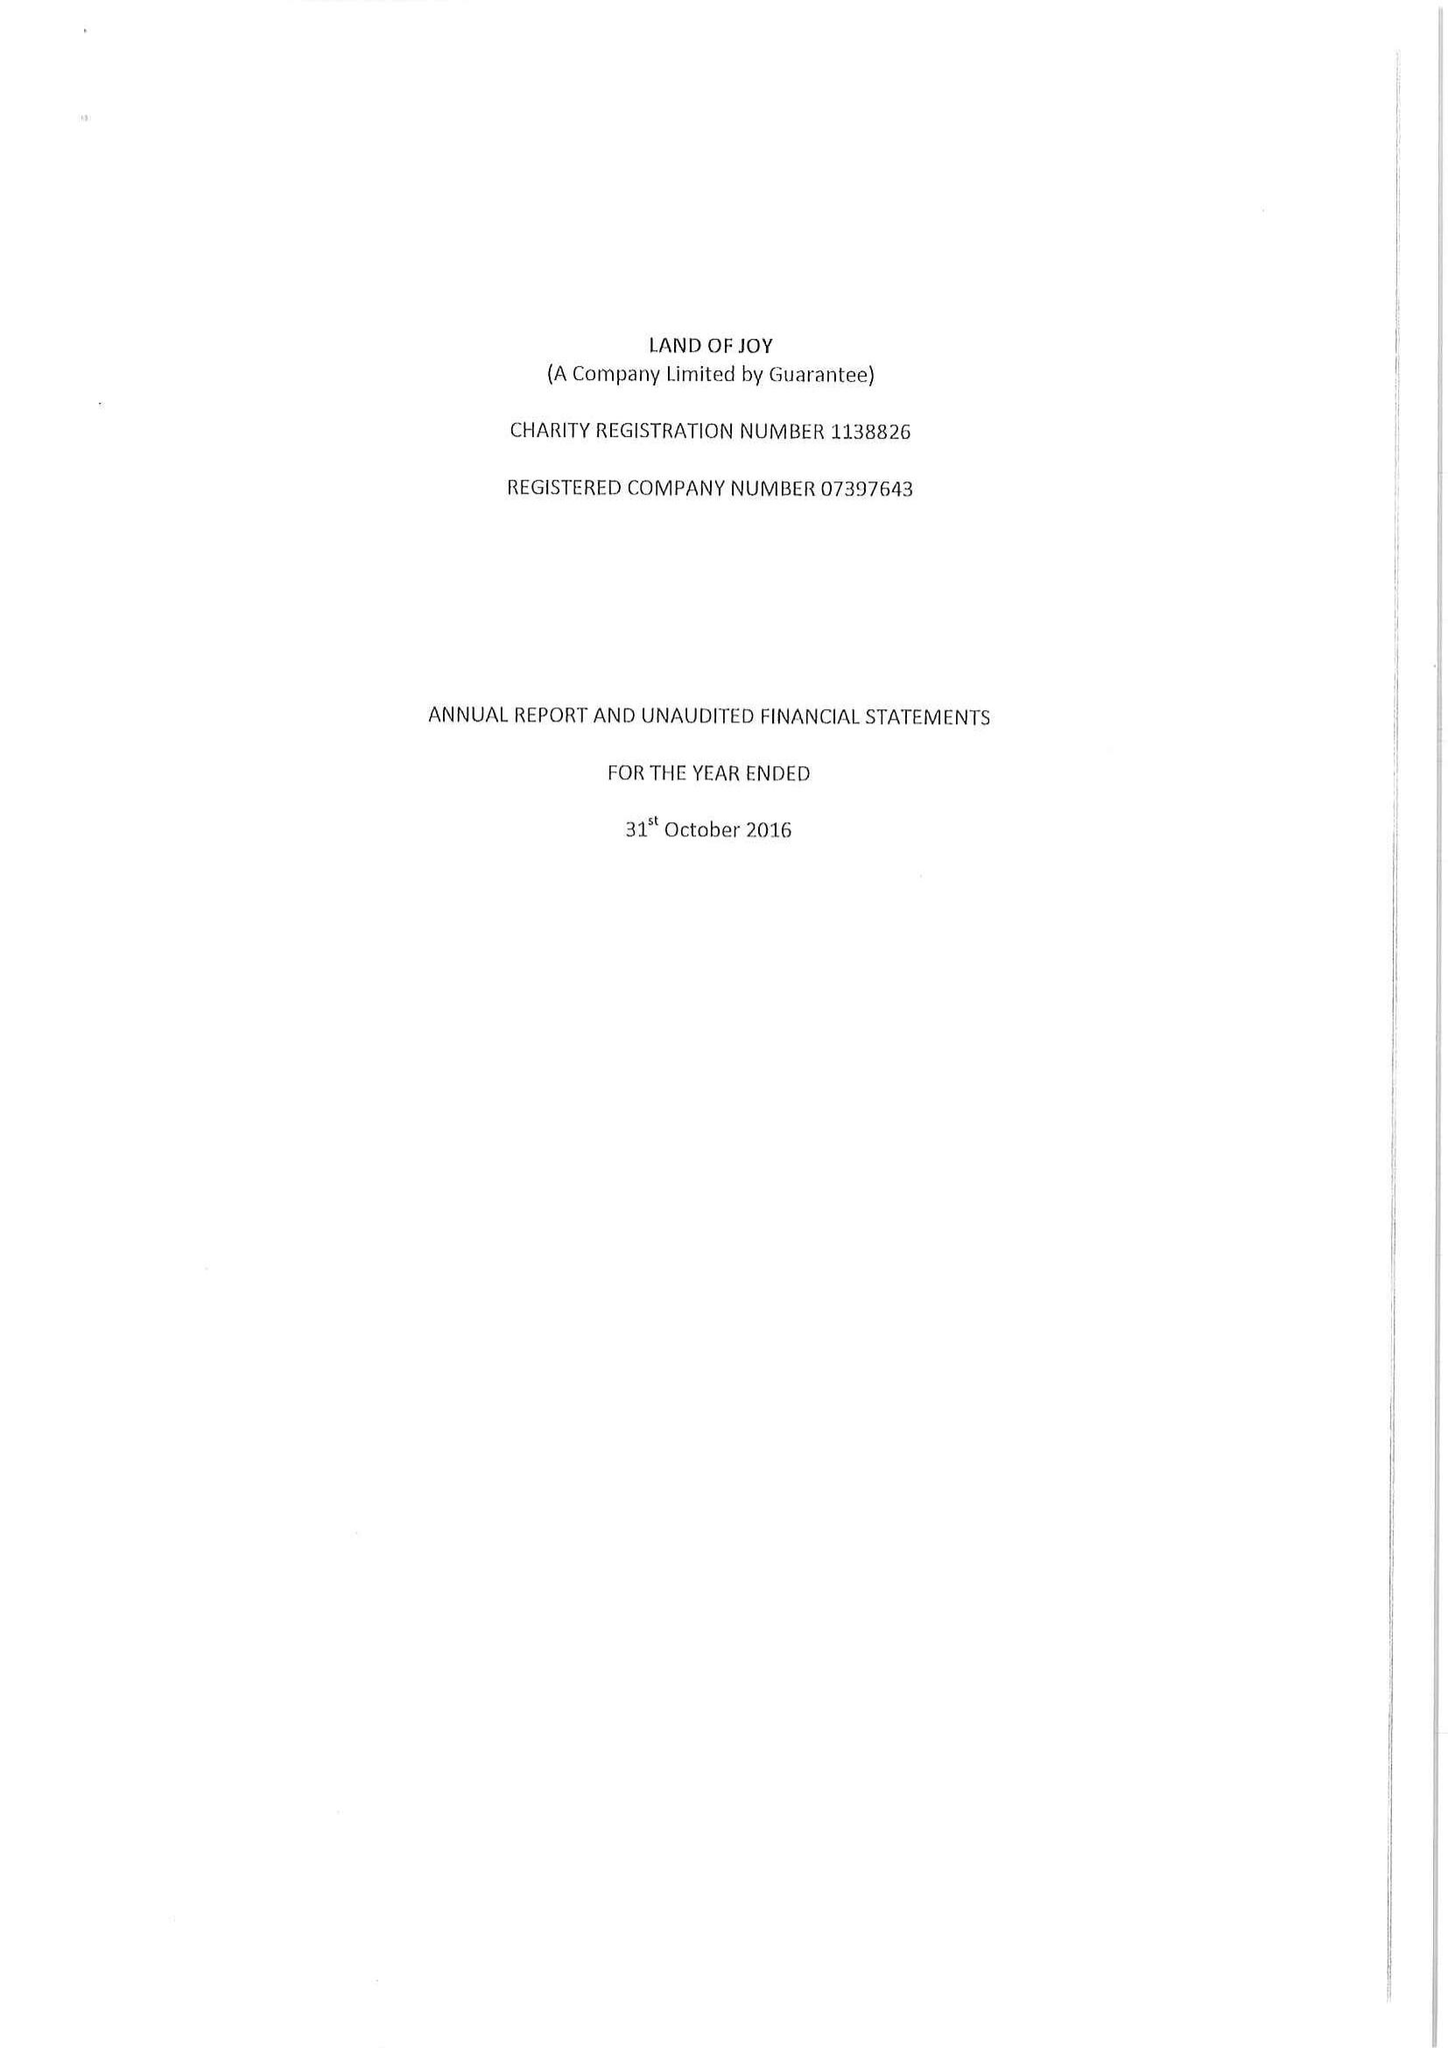What is the value for the address__postcode?
Answer the question using a single word or phrase. NE48 1PP 